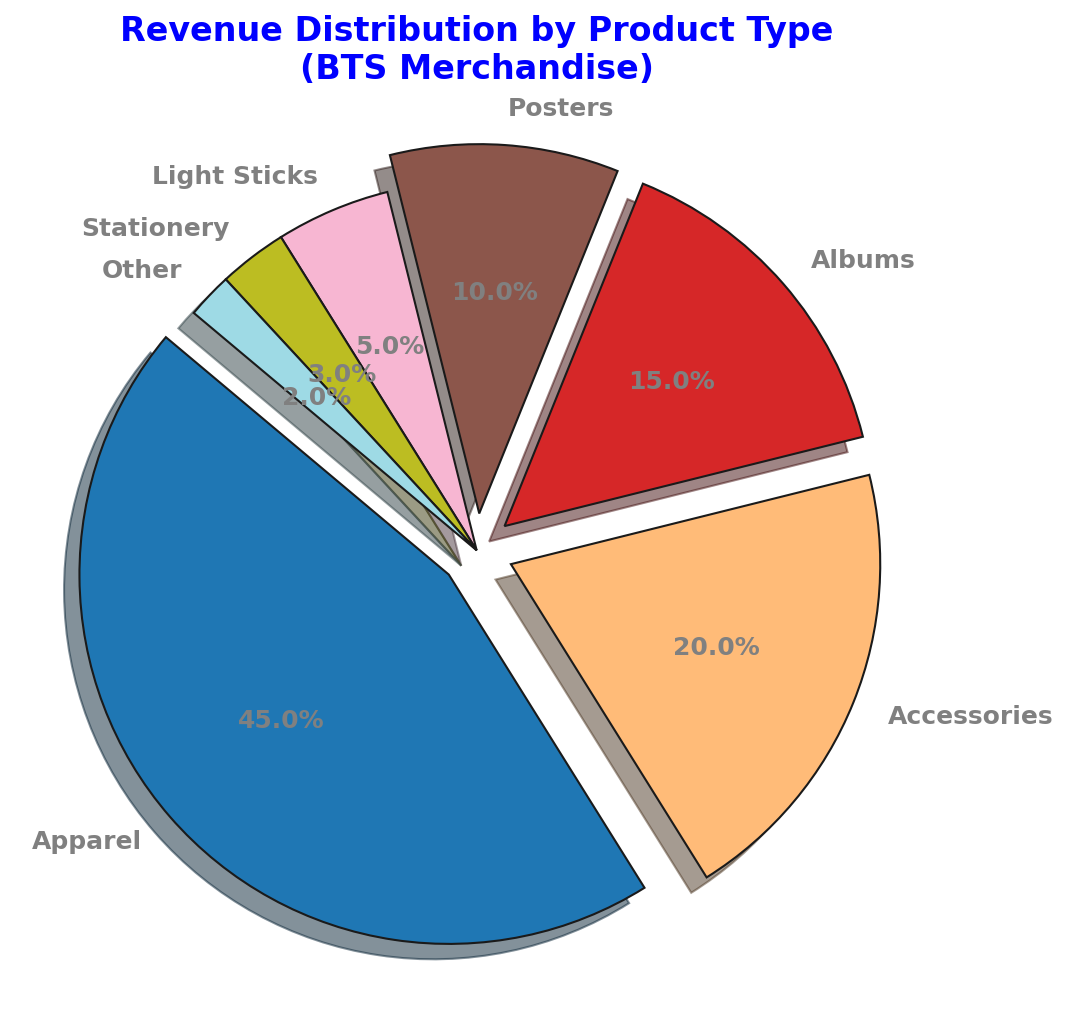How much revenue is generated by apparel and accessories combined? To find the combined revenue from apparel and accessories, we add their respective percentages. Apparel generates 45% and accessories generate 20%. So, the combined revenue is 45% + 20% = 65%
Answer: 65% Which product category generates the least revenue? From the chart, we see that the "Other" category has the smallest slice, which corresponds to 2% of the total revenue.
Answer: Other Is the revenue from albums greater than half of the revenue from apparel? The revenue from albums is 15% and from apparel is 45%. Half of the revenue from apparel is 45% / 2 = 22.5%. Since 15% is less than 22.5%, albums generate less than half of the revenue from apparel.
Answer: No What is the difference in revenue between posters and light sticks? Posters account for 10% of revenue, and light sticks account for 5%. The difference is 10% - 5% = 5%.
Answer: 5% Which product types, combined, generate more revenue than accessories but less than apparel? Accessories generate 20% of the revenue. Products with more than 20% are Apparel (45%) and cumulatively. Albums (15%) and Posters (10%) combined yield 15% + 10% = 25%, which fits our criteria of more than 20% but less than 45%.
Answer: Albums and Posters What is the total revenue percentage of the products with percentages less than 10%? Products with less than 10% are Light Sticks (5%), Stationery (3%), and Other (2%). Summing them up: 5% + 3% + 2% = 10%.
Answer: 10% Which color is used for the 'Apparel' category in the pie chart? In the pie chart, the 'Apparel' category is marked with the first vibrant color from the colormap, which is often the first color in the colormap sequence (usually a shade of blue).
Answer: Blue How many product types individually earn more than 5% of the total revenue? Looking at the chart, we see that Apparel (45%), Accessories (20%), Albums (15%), and Posters (10%) each provide more than 5% revenue. There are 4 such categories.
Answer: 4 What percentage of revenue is generated by non-apparel categories? Apparel accounts for 45%. The remaining categories combined make up the non-apparel revenue: 100% - 45% = 55%.
Answer: 55% Is the combined revenue from stationery and other products greater than light sticks? Stationery contributes 3% and Other 2%. Combining these gives 3% + 2% = 5%. Light Sticks also contribute 5%. Therefore, 5% + 0% = 5%, matches with the revenue from light sticks.
Answer: Equal 